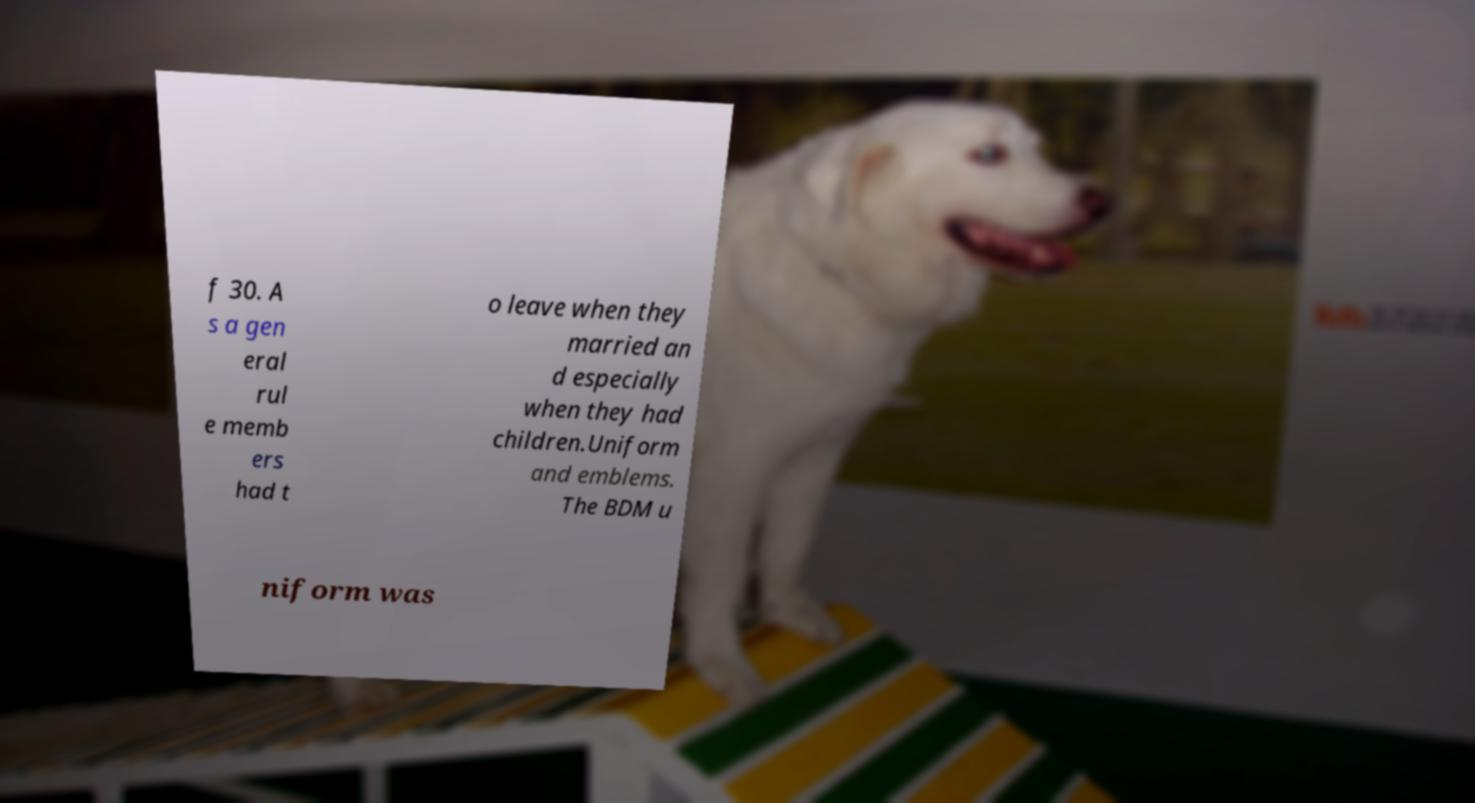Please read and relay the text visible in this image. What does it say? f 30. A s a gen eral rul e memb ers had t o leave when they married an d especially when they had children.Uniform and emblems. The BDM u niform was 